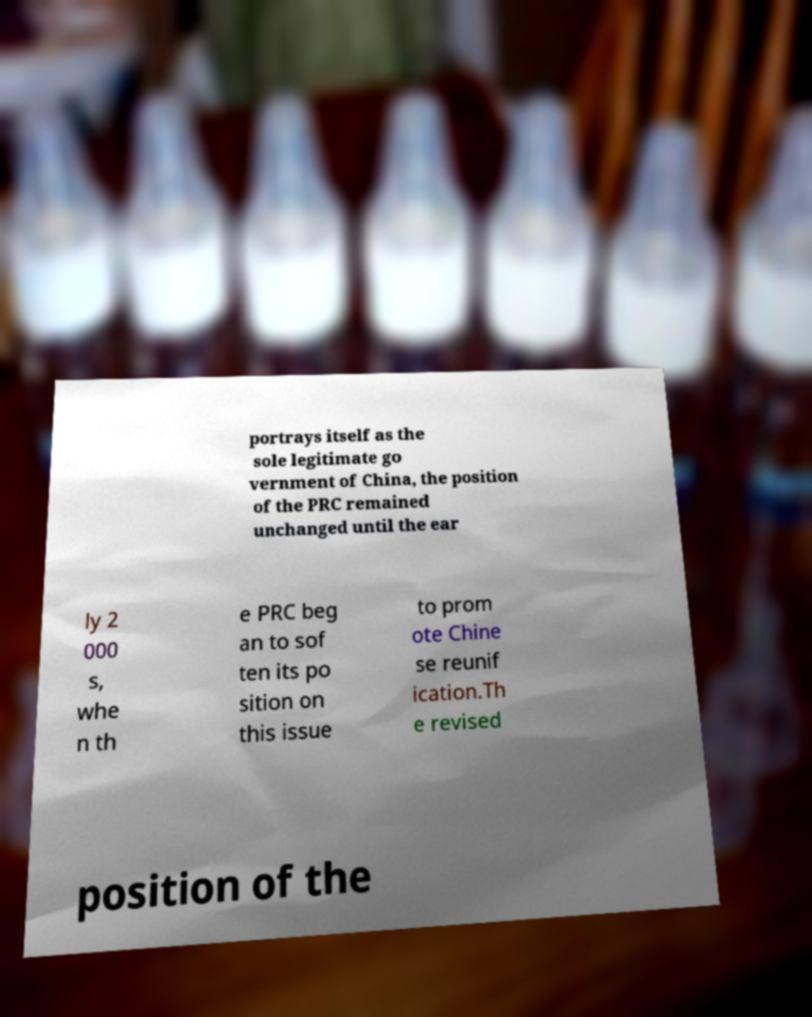There's text embedded in this image that I need extracted. Can you transcribe it verbatim? portrays itself as the sole legitimate go vernment of China, the position of the PRC remained unchanged until the ear ly 2 000 s, whe n th e PRC beg an to sof ten its po sition on this issue to prom ote Chine se reunif ication.Th e revised position of the 